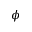Convert formula to latex. <formula><loc_0><loc_0><loc_500><loc_500>\phi</formula> 